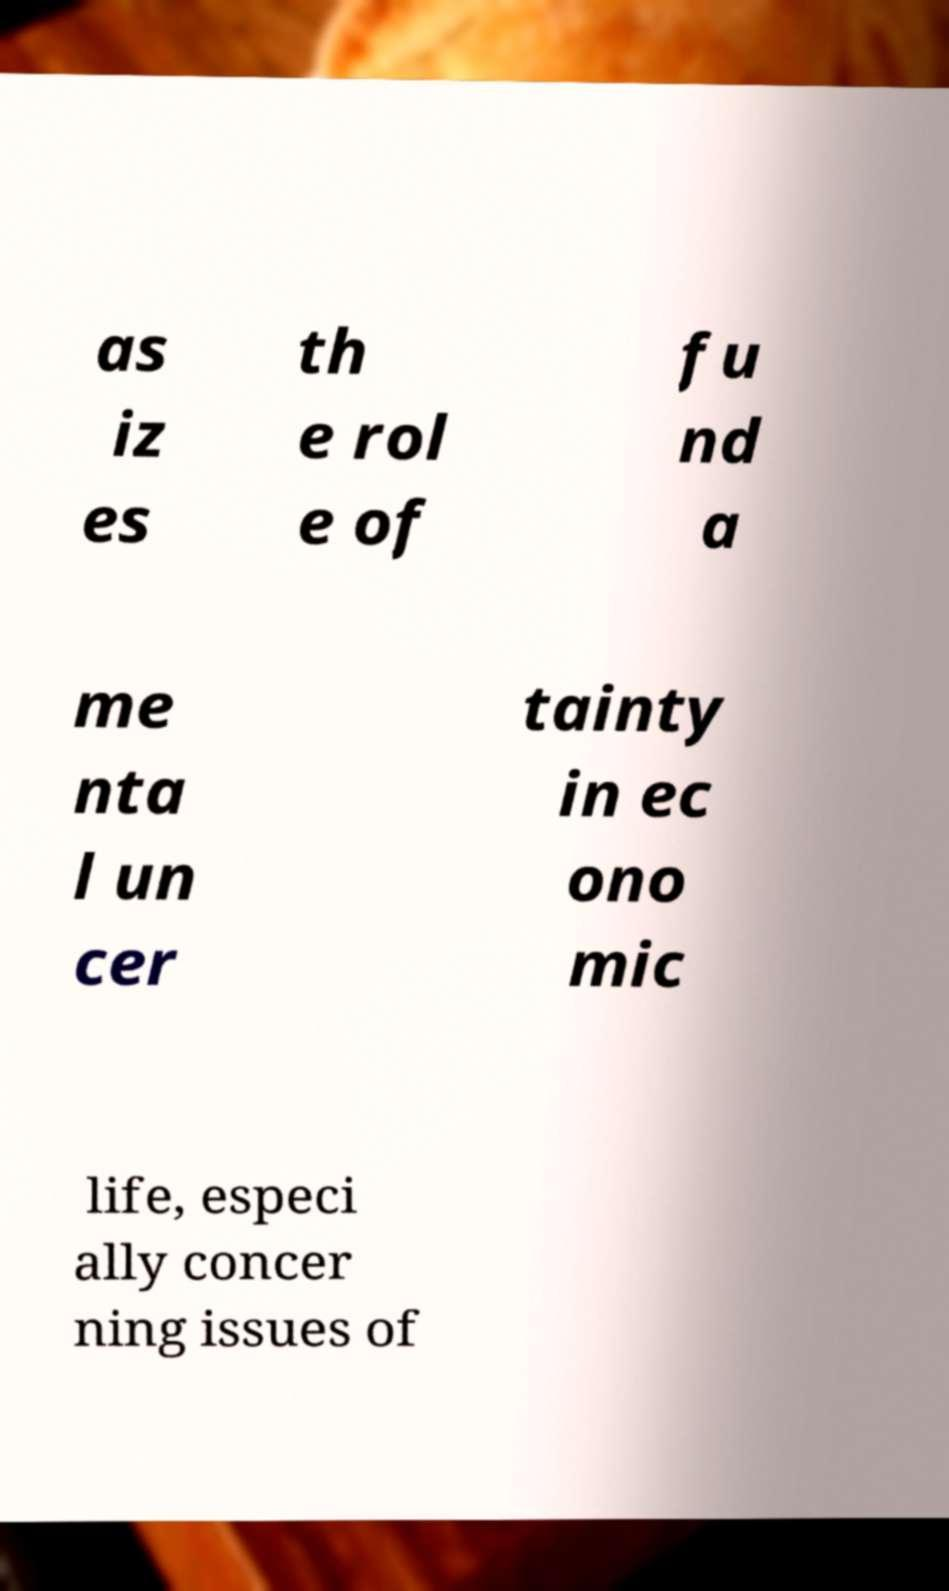Can you read and provide the text displayed in the image?This photo seems to have some interesting text. Can you extract and type it out for me? as iz es th e rol e of fu nd a me nta l un cer tainty in ec ono mic life, especi ally concer ning issues of 